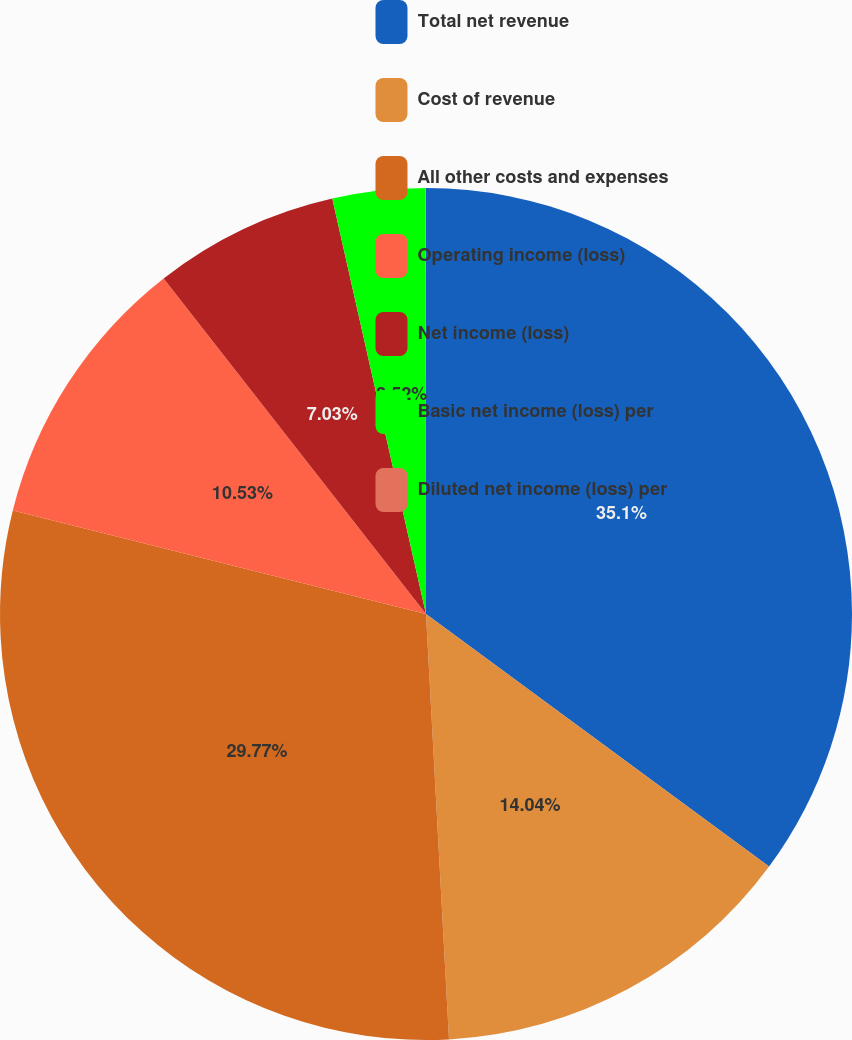Convert chart. <chart><loc_0><loc_0><loc_500><loc_500><pie_chart><fcel>Total net revenue<fcel>Cost of revenue<fcel>All other costs and expenses<fcel>Operating income (loss)<fcel>Net income (loss)<fcel>Basic net income (loss) per<fcel>Diluted net income (loss) per<nl><fcel>35.1%<fcel>14.04%<fcel>29.77%<fcel>10.53%<fcel>7.03%<fcel>3.52%<fcel>0.01%<nl></chart> 